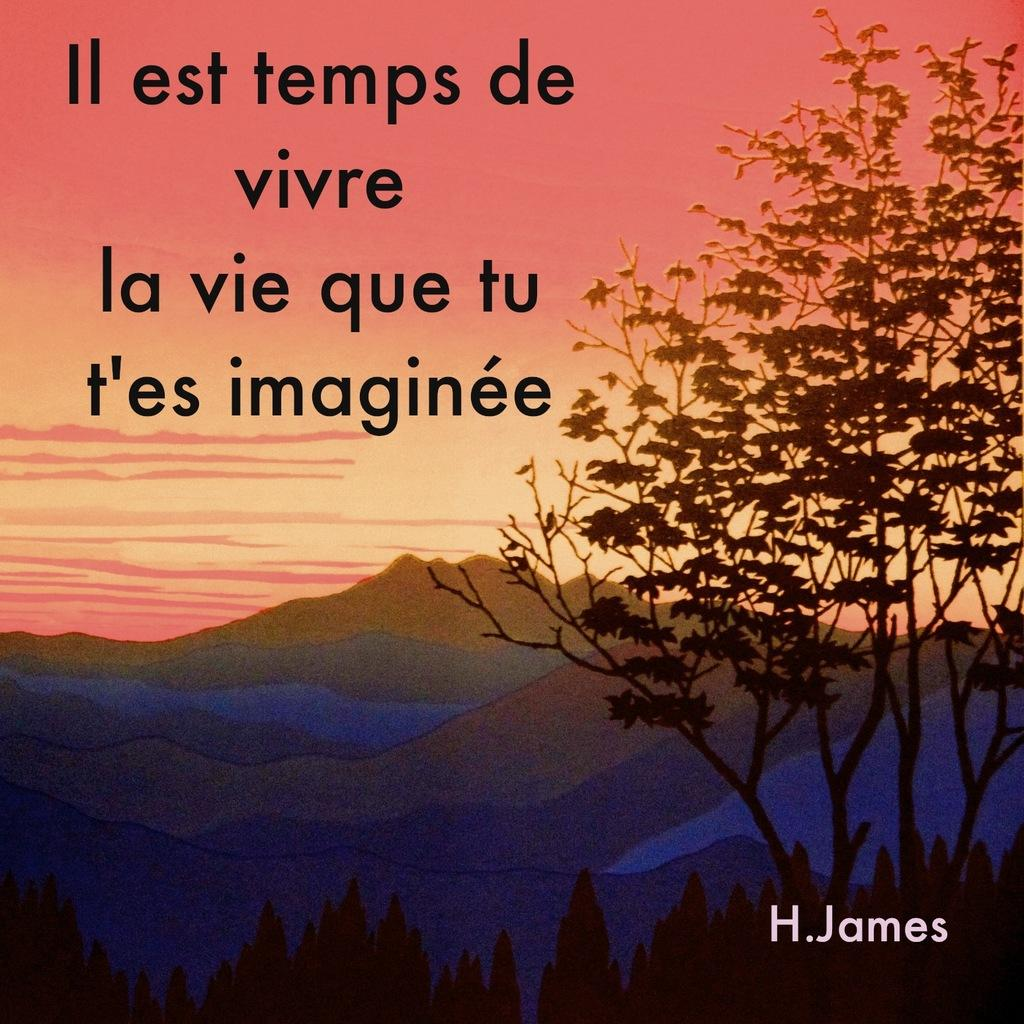What is featured on the poster in the image? There is a poster in the image, which contains mountains, trees, sky, and text. Can you describe the landscape depicted on the poster? The landscape depicted on the poster includes mountains, trees, and sky. What type of information might be conveyed by the text on the poster? The text on the poster might convey information about the landscape, such as its location or significance. What type of clam can be seen holding a crown in the image? There is no clam or crown present in the image; the image features a poster with mountains, trees, sky, and text. What arithmetic problem can be solved using the numbers on the poster? There are no numbers present on the poster in the image, so it is not possible to solve any arithmetic problems based on the information provided. 